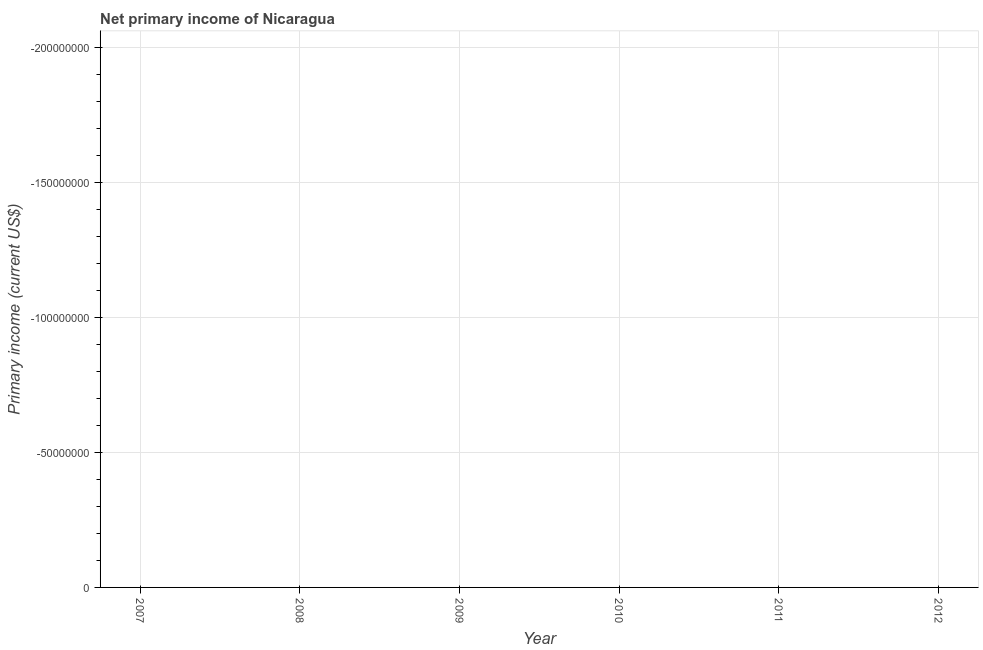What is the average amount of primary income per year?
Your answer should be compact. 0. How many dotlines are there?
Ensure brevity in your answer.  0. How many years are there in the graph?
Offer a very short reply. 6. Are the values on the major ticks of Y-axis written in scientific E-notation?
Provide a succinct answer. No. Does the graph contain any zero values?
Provide a short and direct response. Yes. Does the graph contain grids?
Make the answer very short. Yes. What is the title of the graph?
Your answer should be very brief. Net primary income of Nicaragua. What is the label or title of the Y-axis?
Provide a short and direct response. Primary income (current US$). What is the Primary income (current US$) in 2008?
Your answer should be compact. 0. What is the Primary income (current US$) in 2012?
Give a very brief answer. 0. 